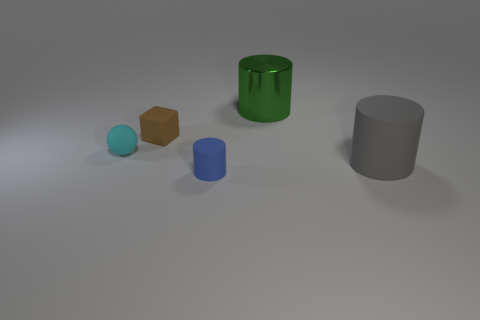Subtract all large cylinders. How many cylinders are left? 1 Add 1 green things. How many objects exist? 6 Subtract 1 blocks. How many blocks are left? 0 Subtract all blocks. How many objects are left? 4 Subtract all tiny blue things. Subtract all matte spheres. How many objects are left? 3 Add 4 small blue objects. How many small blue objects are left? 5 Add 3 large gray things. How many large gray things exist? 4 Subtract 0 purple blocks. How many objects are left? 5 Subtract all blue blocks. Subtract all blue cylinders. How many blocks are left? 1 